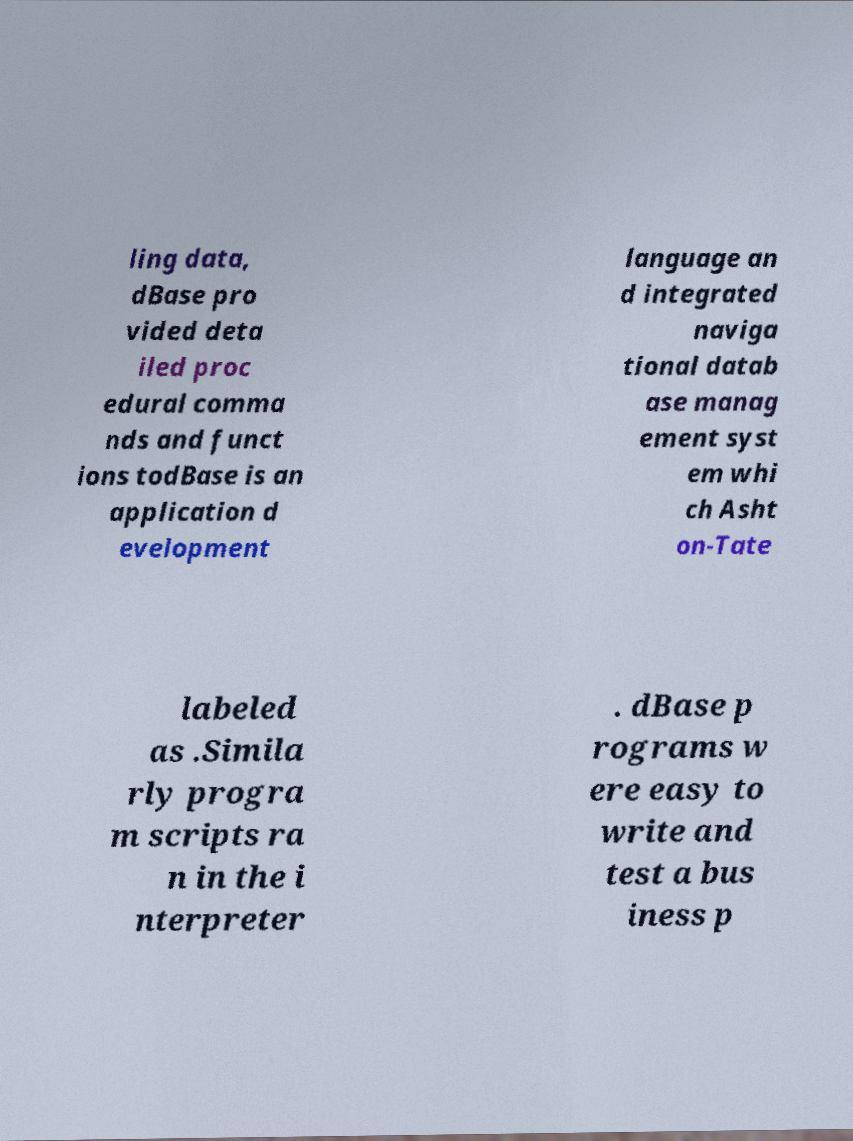Can you read and provide the text displayed in the image?This photo seems to have some interesting text. Can you extract and type it out for me? ling data, dBase pro vided deta iled proc edural comma nds and funct ions todBase is an application d evelopment language an d integrated naviga tional datab ase manag ement syst em whi ch Asht on-Tate labeled as .Simila rly progra m scripts ra n in the i nterpreter . dBase p rograms w ere easy to write and test a bus iness p 